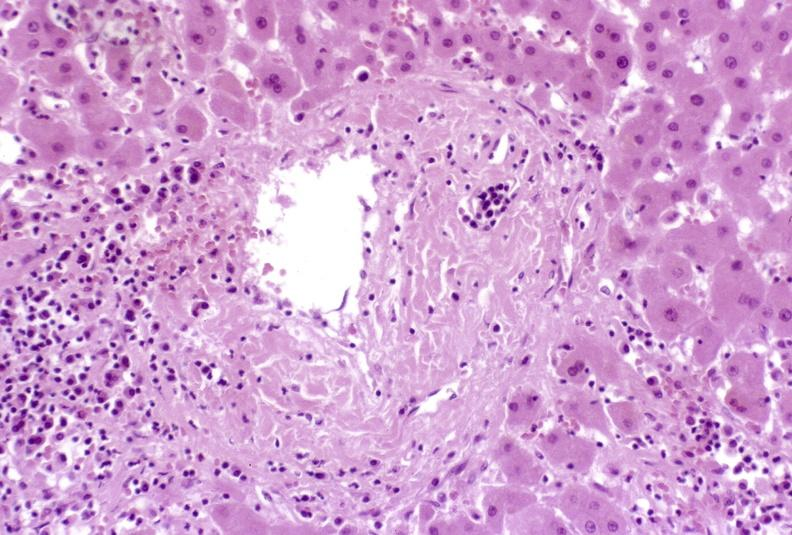what does this image show?
Answer the question using a single word or phrase. Severe acute rejection 